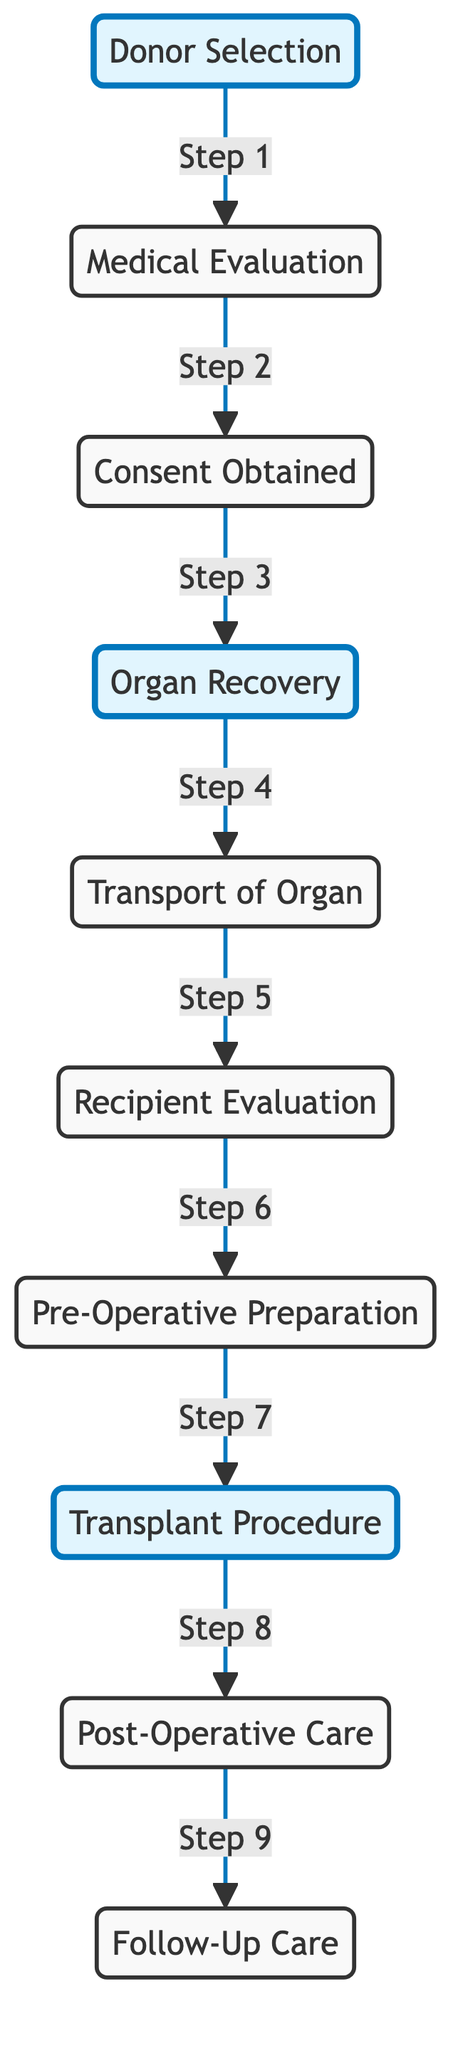What is the first step in the organ transplantation process? The diagram shows that the first step is "Donor Selection," as indicated by the directed edge pointing from the starting node to this node.
Answer: Donor Selection How many nodes are represented in the diagram? By counting all the distinct nodes displayed in the diagram, we find that there are 10 nodes in total representing steps in the transplantation process.
Answer: 10 Which step follows "Consent Obtained"? The directed edge leads from "Consent Obtained" to "Organ Recovery," indicating that this is the next step after consent has been obtained.
Answer: Organ Recovery What is the last step in the organ transplantation process? Following the directed edges from the penultimate node, "Post-Operative Care" leads to the final step, which is "Follow-Up Care."
Answer: Follow-Up Care What connects "Transport of Organ" and "Recipient Evaluation"? The diagram reveals a directed edge from "Transport" to "Recipient Evaluation," illustrating the connection between these two steps as part of the workflow.
Answer: Transport of Organ What is the relationship between "Pre-Operative Preparation" and "Transplant Procedure"? The directed edge shows that "Pre-Operative Preparation" directly precedes "Transplant Procedure," indicating that preparation is a prerequisite for the procedure itself.
Answer: Pre-Operative Preparation How many steps are there between "Donor Selection" and "Transplant Procedure"? By counting the number of directed edges from "Donor Selection" to "Transplant Procedure," we find there are 6 steps in total, traversing through all intermediate nodes in sequence.
Answer: 6 Which node represents the step for evaluation of the recipient? The diagram directly indicates that "Recipient Evaluation" is the node that details the assessment process for the potential recipient's eligibility and readiness for transplantation.
Answer: Recipient Evaluation What step occurs immediately after "Organ Recovery"? The flow indicated in the diagram shows that "Transport of Organ" is the immediate next step following "Organ Recovery," demonstrating the sequential process of moving the organ.
Answer: Transport of Organ 